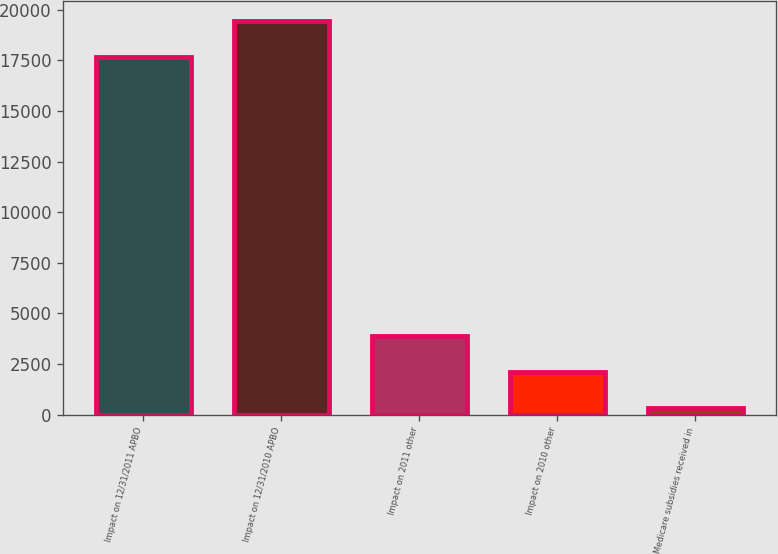<chart> <loc_0><loc_0><loc_500><loc_500><bar_chart><fcel>Impact on 12/31/2011 APBO<fcel>Impact on 12/31/2010 APBO<fcel>Impact on 2011 other<fcel>Impact on 2010 other<fcel>Medicare subsidies received in<nl><fcel>17687<fcel>19453.2<fcel>3868.4<fcel>2102.2<fcel>336<nl></chart> 